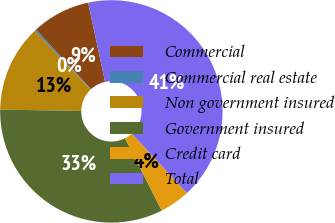Convert chart. <chart><loc_0><loc_0><loc_500><loc_500><pie_chart><fcel>Commercial<fcel>Commercial real estate<fcel>Non government insured<fcel>Government insured<fcel>Credit card<fcel>Total<nl><fcel>8.51%<fcel>0.26%<fcel>12.63%<fcel>32.73%<fcel>4.39%<fcel>41.48%<nl></chart> 